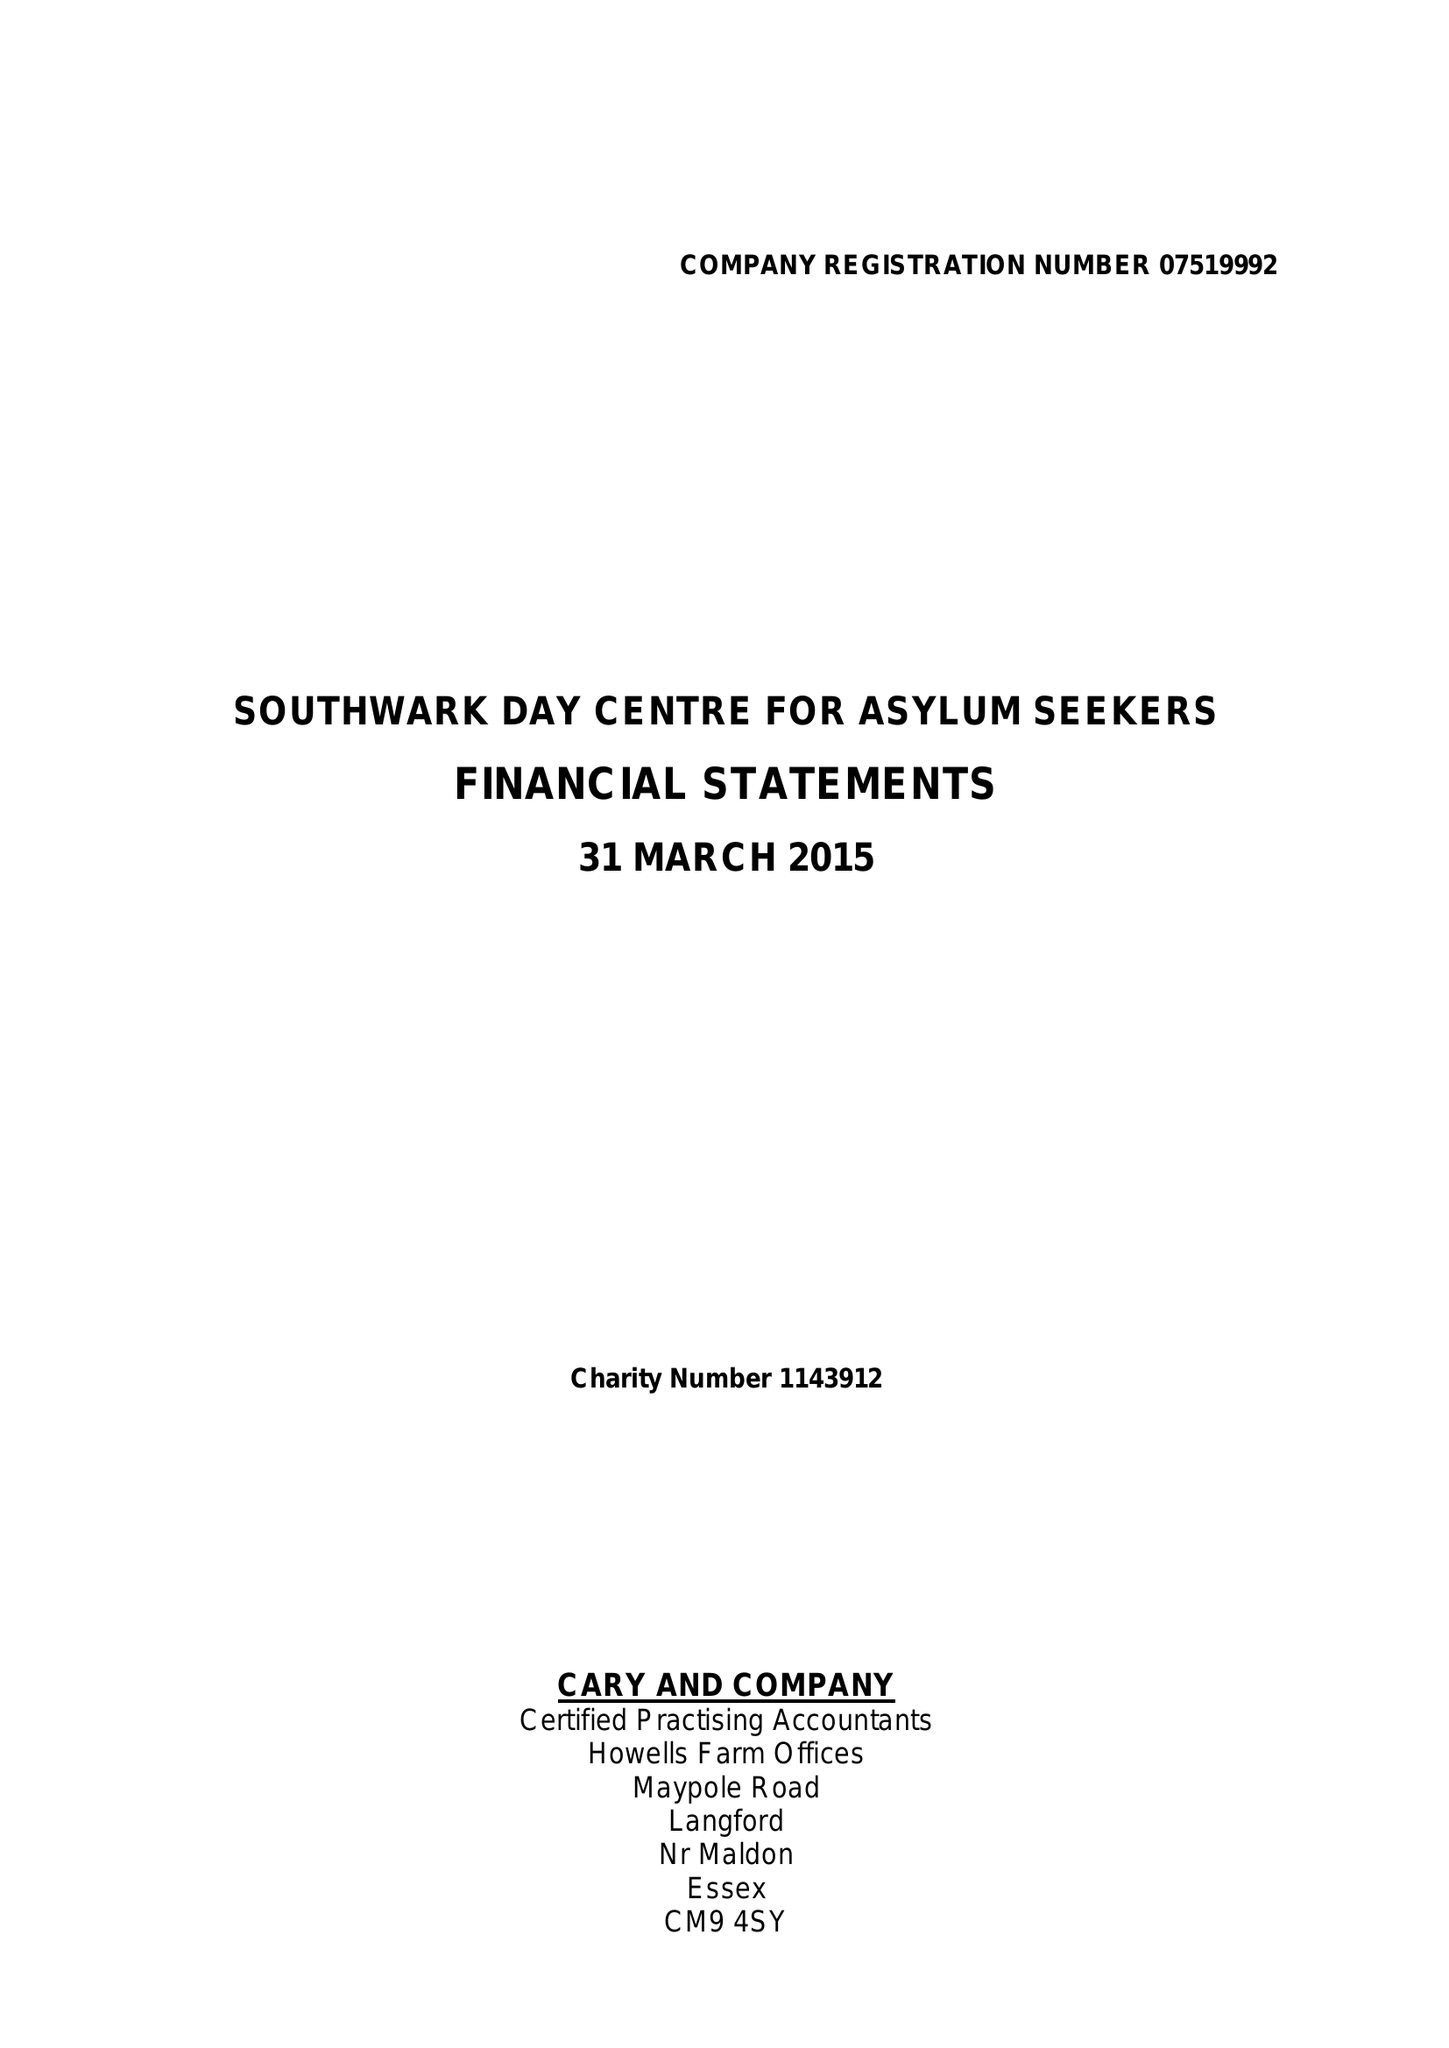What is the value for the charity_name?
Answer the question using a single word or phrase. Southwark Day Centre For Asylum Seekers 